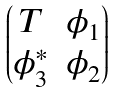Convert formula to latex. <formula><loc_0><loc_0><loc_500><loc_500>\begin{pmatrix} T & \phi _ { 1 } \\ \phi _ { 3 } ^ { * } & \phi _ { 2 } \end{pmatrix}</formula> 